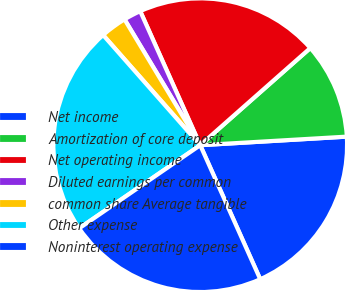Convert chart to OTSL. <chart><loc_0><loc_0><loc_500><loc_500><pie_chart><fcel>Net income<fcel>Amortization of core deposit<fcel>Net operating income<fcel>Diluted earnings per common<fcel>common share Average tangible<fcel>Other expense<fcel>Noninterest operating expense<nl><fcel>19.23%<fcel>10.58%<fcel>20.19%<fcel>1.92%<fcel>2.88%<fcel>23.08%<fcel>22.12%<nl></chart> 